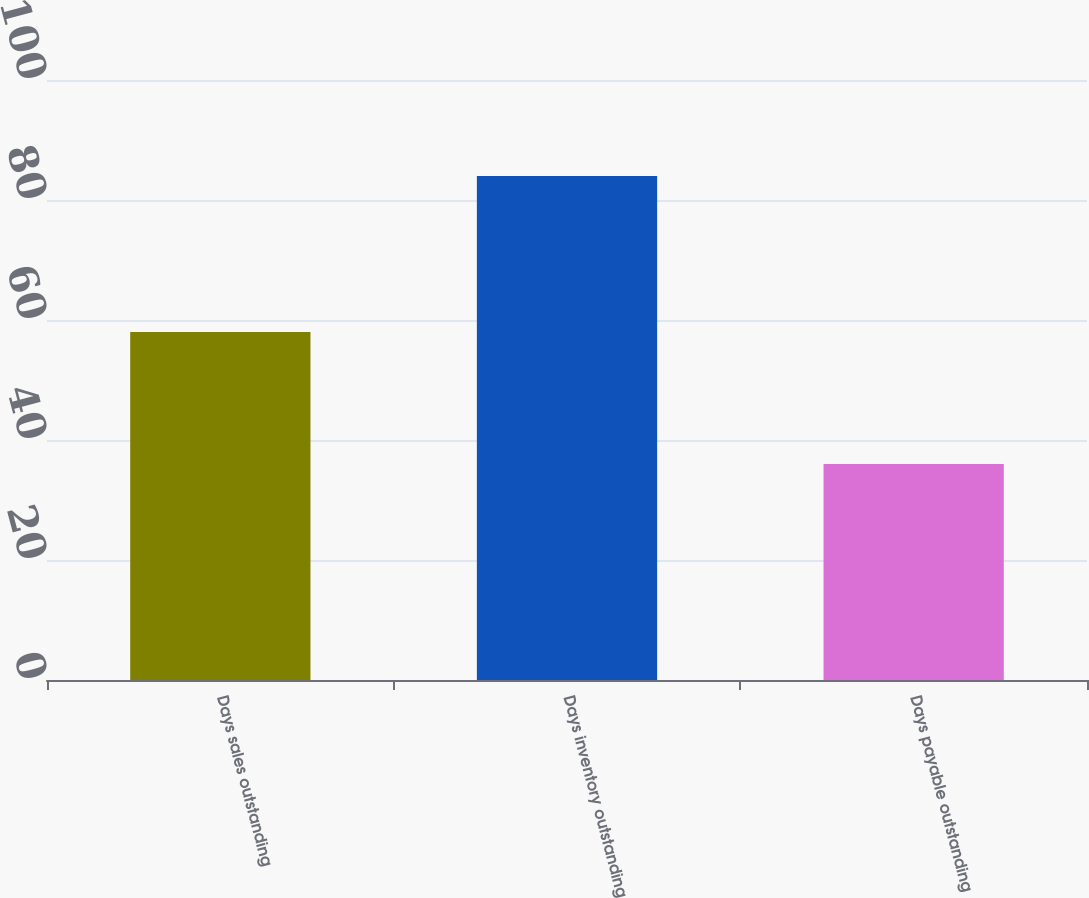Convert chart to OTSL. <chart><loc_0><loc_0><loc_500><loc_500><bar_chart><fcel>Days sales outstanding<fcel>Days inventory outstanding<fcel>Days payable outstanding<nl><fcel>58<fcel>84<fcel>36<nl></chart> 